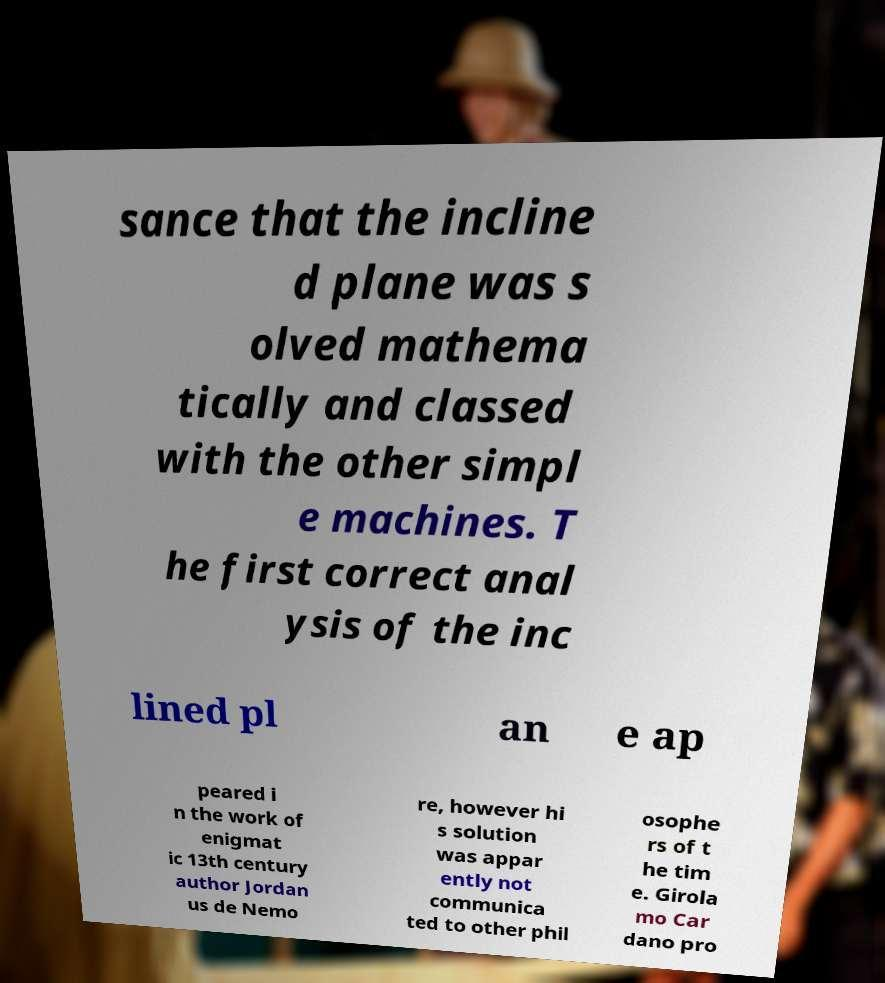What messages or text are displayed in this image? I need them in a readable, typed format. sance that the incline d plane was s olved mathema tically and classed with the other simpl e machines. T he first correct anal ysis of the inc lined pl an e ap peared i n the work of enigmat ic 13th century author Jordan us de Nemo re, however hi s solution was appar ently not communica ted to other phil osophe rs of t he tim e. Girola mo Car dano pro 